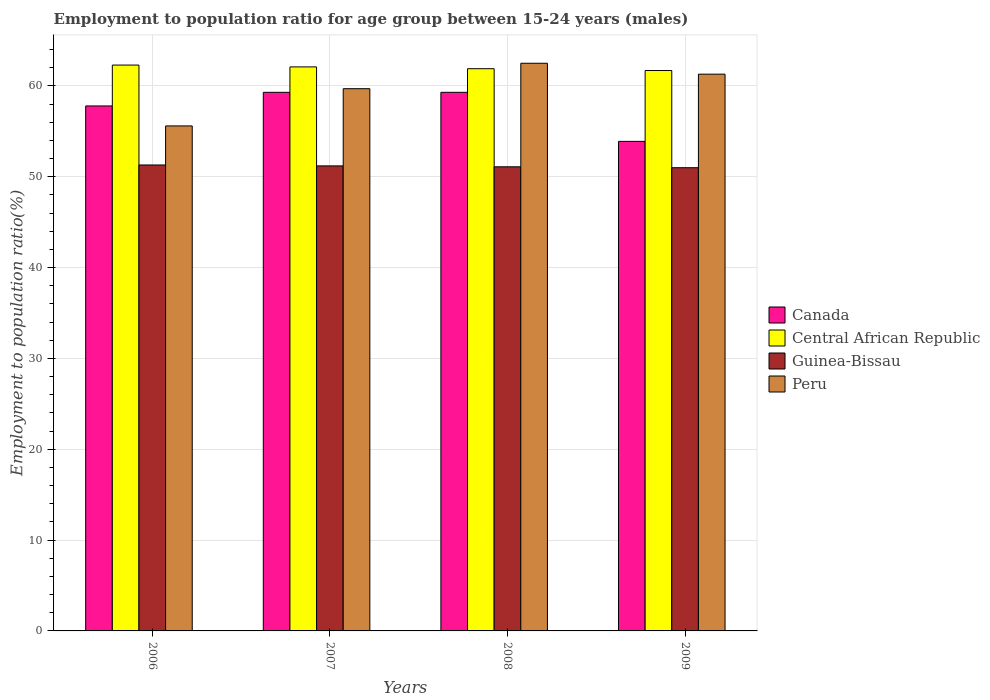How many different coloured bars are there?
Provide a short and direct response. 4. How many groups of bars are there?
Offer a terse response. 4. How many bars are there on the 4th tick from the right?
Your answer should be very brief. 4. In how many cases, is the number of bars for a given year not equal to the number of legend labels?
Offer a very short reply. 0. What is the employment to population ratio in Canada in 2006?
Ensure brevity in your answer.  57.8. Across all years, what is the maximum employment to population ratio in Guinea-Bissau?
Give a very brief answer. 51.3. Across all years, what is the minimum employment to population ratio in Canada?
Offer a terse response. 53.9. What is the total employment to population ratio in Canada in the graph?
Provide a short and direct response. 230.3. What is the difference between the employment to population ratio in Guinea-Bissau in 2006 and that in 2009?
Make the answer very short. 0.3. What is the difference between the employment to population ratio in Central African Republic in 2007 and the employment to population ratio in Canada in 2006?
Ensure brevity in your answer.  4.3. What is the average employment to population ratio in Peru per year?
Give a very brief answer. 59.77. In how many years, is the employment to population ratio in Guinea-Bissau greater than 12 %?
Provide a succinct answer. 4. What is the ratio of the employment to population ratio in Guinea-Bissau in 2006 to that in 2008?
Provide a succinct answer. 1. What is the difference between the highest and the second highest employment to population ratio in Central African Republic?
Keep it short and to the point. 0.2. What is the difference between the highest and the lowest employment to population ratio in Canada?
Provide a short and direct response. 5.4. In how many years, is the employment to population ratio in Central African Republic greater than the average employment to population ratio in Central African Republic taken over all years?
Keep it short and to the point. 2. Is the sum of the employment to population ratio in Canada in 2006 and 2007 greater than the maximum employment to population ratio in Peru across all years?
Keep it short and to the point. Yes. What does the 2nd bar from the left in 2008 represents?
Keep it short and to the point. Central African Republic. What does the 3rd bar from the right in 2006 represents?
Keep it short and to the point. Central African Republic. Are all the bars in the graph horizontal?
Your answer should be very brief. No. Does the graph contain any zero values?
Provide a short and direct response. No. What is the title of the graph?
Give a very brief answer. Employment to population ratio for age group between 15-24 years (males). What is the label or title of the X-axis?
Keep it short and to the point. Years. What is the label or title of the Y-axis?
Offer a very short reply. Employment to population ratio(%). What is the Employment to population ratio(%) in Canada in 2006?
Your answer should be compact. 57.8. What is the Employment to population ratio(%) of Central African Republic in 2006?
Offer a very short reply. 62.3. What is the Employment to population ratio(%) of Guinea-Bissau in 2006?
Give a very brief answer. 51.3. What is the Employment to population ratio(%) in Peru in 2006?
Provide a short and direct response. 55.6. What is the Employment to population ratio(%) of Canada in 2007?
Offer a terse response. 59.3. What is the Employment to population ratio(%) of Central African Republic in 2007?
Provide a short and direct response. 62.1. What is the Employment to population ratio(%) of Guinea-Bissau in 2007?
Your answer should be very brief. 51.2. What is the Employment to population ratio(%) of Peru in 2007?
Your answer should be very brief. 59.7. What is the Employment to population ratio(%) in Canada in 2008?
Make the answer very short. 59.3. What is the Employment to population ratio(%) in Central African Republic in 2008?
Keep it short and to the point. 61.9. What is the Employment to population ratio(%) in Guinea-Bissau in 2008?
Your response must be concise. 51.1. What is the Employment to population ratio(%) of Peru in 2008?
Offer a very short reply. 62.5. What is the Employment to population ratio(%) in Canada in 2009?
Give a very brief answer. 53.9. What is the Employment to population ratio(%) of Central African Republic in 2009?
Give a very brief answer. 61.7. What is the Employment to population ratio(%) of Guinea-Bissau in 2009?
Keep it short and to the point. 51. What is the Employment to population ratio(%) in Peru in 2009?
Provide a short and direct response. 61.3. Across all years, what is the maximum Employment to population ratio(%) in Canada?
Make the answer very short. 59.3. Across all years, what is the maximum Employment to population ratio(%) of Central African Republic?
Your answer should be very brief. 62.3. Across all years, what is the maximum Employment to population ratio(%) in Guinea-Bissau?
Make the answer very short. 51.3. Across all years, what is the maximum Employment to population ratio(%) of Peru?
Offer a terse response. 62.5. Across all years, what is the minimum Employment to population ratio(%) of Canada?
Your answer should be compact. 53.9. Across all years, what is the minimum Employment to population ratio(%) of Central African Republic?
Your response must be concise. 61.7. Across all years, what is the minimum Employment to population ratio(%) of Guinea-Bissau?
Provide a short and direct response. 51. Across all years, what is the minimum Employment to population ratio(%) in Peru?
Offer a terse response. 55.6. What is the total Employment to population ratio(%) of Canada in the graph?
Your answer should be very brief. 230.3. What is the total Employment to population ratio(%) in Central African Republic in the graph?
Keep it short and to the point. 248. What is the total Employment to population ratio(%) of Guinea-Bissau in the graph?
Your answer should be very brief. 204.6. What is the total Employment to population ratio(%) of Peru in the graph?
Your answer should be very brief. 239.1. What is the difference between the Employment to population ratio(%) in Canada in 2006 and that in 2008?
Your answer should be very brief. -1.5. What is the difference between the Employment to population ratio(%) of Central African Republic in 2006 and that in 2008?
Ensure brevity in your answer.  0.4. What is the difference between the Employment to population ratio(%) in Guinea-Bissau in 2006 and that in 2008?
Offer a very short reply. 0.2. What is the difference between the Employment to population ratio(%) in Peru in 2006 and that in 2008?
Give a very brief answer. -6.9. What is the difference between the Employment to population ratio(%) of Central African Republic in 2006 and that in 2009?
Your answer should be compact. 0.6. What is the difference between the Employment to population ratio(%) in Peru in 2006 and that in 2009?
Ensure brevity in your answer.  -5.7. What is the difference between the Employment to population ratio(%) of Canada in 2007 and that in 2008?
Provide a succinct answer. 0. What is the difference between the Employment to population ratio(%) in Guinea-Bissau in 2007 and that in 2008?
Provide a succinct answer. 0.1. What is the difference between the Employment to population ratio(%) in Peru in 2007 and that in 2008?
Give a very brief answer. -2.8. What is the difference between the Employment to population ratio(%) in Canada in 2007 and that in 2009?
Provide a succinct answer. 5.4. What is the difference between the Employment to population ratio(%) in Central African Republic in 2007 and that in 2009?
Your response must be concise. 0.4. What is the difference between the Employment to population ratio(%) in Guinea-Bissau in 2007 and that in 2009?
Provide a short and direct response. 0.2. What is the difference between the Employment to population ratio(%) in Peru in 2007 and that in 2009?
Your answer should be compact. -1.6. What is the difference between the Employment to population ratio(%) of Canada in 2008 and that in 2009?
Ensure brevity in your answer.  5.4. What is the difference between the Employment to population ratio(%) in Central African Republic in 2008 and that in 2009?
Your answer should be very brief. 0.2. What is the difference between the Employment to population ratio(%) of Peru in 2008 and that in 2009?
Offer a very short reply. 1.2. What is the difference between the Employment to population ratio(%) in Canada in 2006 and the Employment to population ratio(%) in Guinea-Bissau in 2008?
Your response must be concise. 6.7. What is the difference between the Employment to population ratio(%) in Central African Republic in 2006 and the Employment to population ratio(%) in Peru in 2008?
Make the answer very short. -0.2. What is the difference between the Employment to population ratio(%) of Guinea-Bissau in 2006 and the Employment to population ratio(%) of Peru in 2008?
Provide a short and direct response. -11.2. What is the difference between the Employment to population ratio(%) of Canada in 2006 and the Employment to population ratio(%) of Guinea-Bissau in 2009?
Make the answer very short. 6.8. What is the difference between the Employment to population ratio(%) in Central African Republic in 2006 and the Employment to population ratio(%) in Guinea-Bissau in 2009?
Ensure brevity in your answer.  11.3. What is the difference between the Employment to population ratio(%) of Central African Republic in 2007 and the Employment to population ratio(%) of Guinea-Bissau in 2008?
Your response must be concise. 11. What is the difference between the Employment to population ratio(%) in Central African Republic in 2007 and the Employment to population ratio(%) in Peru in 2008?
Keep it short and to the point. -0.4. What is the difference between the Employment to population ratio(%) of Canada in 2007 and the Employment to population ratio(%) of Central African Republic in 2009?
Your answer should be very brief. -2.4. What is the difference between the Employment to population ratio(%) of Canada in 2007 and the Employment to population ratio(%) of Guinea-Bissau in 2009?
Offer a very short reply. 8.3. What is the difference between the Employment to population ratio(%) in Canada in 2007 and the Employment to population ratio(%) in Peru in 2009?
Make the answer very short. -2. What is the difference between the Employment to population ratio(%) in Central African Republic in 2007 and the Employment to population ratio(%) in Guinea-Bissau in 2009?
Your answer should be compact. 11.1. What is the difference between the Employment to population ratio(%) in Guinea-Bissau in 2007 and the Employment to population ratio(%) in Peru in 2009?
Offer a terse response. -10.1. What is the difference between the Employment to population ratio(%) of Canada in 2008 and the Employment to population ratio(%) of Central African Republic in 2009?
Your response must be concise. -2.4. What is the difference between the Employment to population ratio(%) of Canada in 2008 and the Employment to population ratio(%) of Peru in 2009?
Offer a terse response. -2. What is the difference between the Employment to population ratio(%) of Central African Republic in 2008 and the Employment to population ratio(%) of Peru in 2009?
Your answer should be compact. 0.6. What is the average Employment to population ratio(%) in Canada per year?
Keep it short and to the point. 57.58. What is the average Employment to population ratio(%) in Guinea-Bissau per year?
Your answer should be very brief. 51.15. What is the average Employment to population ratio(%) of Peru per year?
Your answer should be compact. 59.77. In the year 2006, what is the difference between the Employment to population ratio(%) of Canada and Employment to population ratio(%) of Central African Republic?
Offer a terse response. -4.5. In the year 2006, what is the difference between the Employment to population ratio(%) in Central African Republic and Employment to population ratio(%) in Guinea-Bissau?
Provide a succinct answer. 11. In the year 2006, what is the difference between the Employment to population ratio(%) of Central African Republic and Employment to population ratio(%) of Peru?
Your answer should be compact. 6.7. In the year 2006, what is the difference between the Employment to population ratio(%) in Guinea-Bissau and Employment to population ratio(%) in Peru?
Your answer should be very brief. -4.3. In the year 2007, what is the difference between the Employment to population ratio(%) of Canada and Employment to population ratio(%) of Peru?
Offer a terse response. -0.4. In the year 2007, what is the difference between the Employment to population ratio(%) in Guinea-Bissau and Employment to population ratio(%) in Peru?
Offer a very short reply. -8.5. In the year 2008, what is the difference between the Employment to population ratio(%) in Canada and Employment to population ratio(%) in Central African Republic?
Keep it short and to the point. -2.6. In the year 2008, what is the difference between the Employment to population ratio(%) of Canada and Employment to population ratio(%) of Peru?
Give a very brief answer. -3.2. In the year 2008, what is the difference between the Employment to population ratio(%) in Guinea-Bissau and Employment to population ratio(%) in Peru?
Your answer should be compact. -11.4. In the year 2009, what is the difference between the Employment to population ratio(%) of Canada and Employment to population ratio(%) of Central African Republic?
Provide a succinct answer. -7.8. In the year 2009, what is the difference between the Employment to population ratio(%) of Canada and Employment to population ratio(%) of Guinea-Bissau?
Provide a short and direct response. 2.9. In the year 2009, what is the difference between the Employment to population ratio(%) in Central African Republic and Employment to population ratio(%) in Guinea-Bissau?
Your answer should be compact. 10.7. In the year 2009, what is the difference between the Employment to population ratio(%) in Guinea-Bissau and Employment to population ratio(%) in Peru?
Offer a terse response. -10.3. What is the ratio of the Employment to population ratio(%) in Canada in 2006 to that in 2007?
Provide a short and direct response. 0.97. What is the ratio of the Employment to population ratio(%) of Central African Republic in 2006 to that in 2007?
Keep it short and to the point. 1. What is the ratio of the Employment to population ratio(%) in Peru in 2006 to that in 2007?
Ensure brevity in your answer.  0.93. What is the ratio of the Employment to population ratio(%) in Canada in 2006 to that in 2008?
Provide a succinct answer. 0.97. What is the ratio of the Employment to population ratio(%) in Central African Republic in 2006 to that in 2008?
Your answer should be very brief. 1.01. What is the ratio of the Employment to population ratio(%) of Guinea-Bissau in 2006 to that in 2008?
Make the answer very short. 1. What is the ratio of the Employment to population ratio(%) in Peru in 2006 to that in 2008?
Your response must be concise. 0.89. What is the ratio of the Employment to population ratio(%) in Canada in 2006 to that in 2009?
Provide a short and direct response. 1.07. What is the ratio of the Employment to population ratio(%) of Central African Republic in 2006 to that in 2009?
Ensure brevity in your answer.  1.01. What is the ratio of the Employment to population ratio(%) of Guinea-Bissau in 2006 to that in 2009?
Your answer should be very brief. 1.01. What is the ratio of the Employment to population ratio(%) of Peru in 2006 to that in 2009?
Make the answer very short. 0.91. What is the ratio of the Employment to population ratio(%) in Central African Republic in 2007 to that in 2008?
Ensure brevity in your answer.  1. What is the ratio of the Employment to population ratio(%) in Peru in 2007 to that in 2008?
Your answer should be very brief. 0.96. What is the ratio of the Employment to population ratio(%) of Canada in 2007 to that in 2009?
Provide a short and direct response. 1.1. What is the ratio of the Employment to population ratio(%) of Guinea-Bissau in 2007 to that in 2009?
Your answer should be compact. 1. What is the ratio of the Employment to population ratio(%) of Peru in 2007 to that in 2009?
Make the answer very short. 0.97. What is the ratio of the Employment to population ratio(%) in Canada in 2008 to that in 2009?
Ensure brevity in your answer.  1.1. What is the ratio of the Employment to population ratio(%) in Central African Republic in 2008 to that in 2009?
Your response must be concise. 1. What is the ratio of the Employment to population ratio(%) in Guinea-Bissau in 2008 to that in 2009?
Provide a succinct answer. 1. What is the ratio of the Employment to population ratio(%) of Peru in 2008 to that in 2009?
Give a very brief answer. 1.02. What is the difference between the highest and the second highest Employment to population ratio(%) in Canada?
Offer a very short reply. 0. What is the difference between the highest and the second highest Employment to population ratio(%) in Central African Republic?
Keep it short and to the point. 0.2. What is the difference between the highest and the second highest Employment to population ratio(%) of Peru?
Ensure brevity in your answer.  1.2. What is the difference between the highest and the lowest Employment to population ratio(%) in Canada?
Provide a succinct answer. 5.4. 